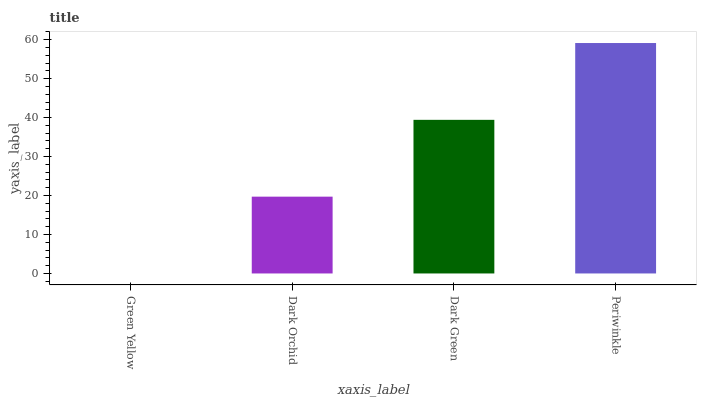Is Green Yellow the minimum?
Answer yes or no. Yes. Is Periwinkle the maximum?
Answer yes or no. Yes. Is Dark Orchid the minimum?
Answer yes or no. No. Is Dark Orchid the maximum?
Answer yes or no. No. Is Dark Orchid greater than Green Yellow?
Answer yes or no. Yes. Is Green Yellow less than Dark Orchid?
Answer yes or no. Yes. Is Green Yellow greater than Dark Orchid?
Answer yes or no. No. Is Dark Orchid less than Green Yellow?
Answer yes or no. No. Is Dark Green the high median?
Answer yes or no. Yes. Is Dark Orchid the low median?
Answer yes or no. Yes. Is Dark Orchid the high median?
Answer yes or no. No. Is Periwinkle the low median?
Answer yes or no. No. 